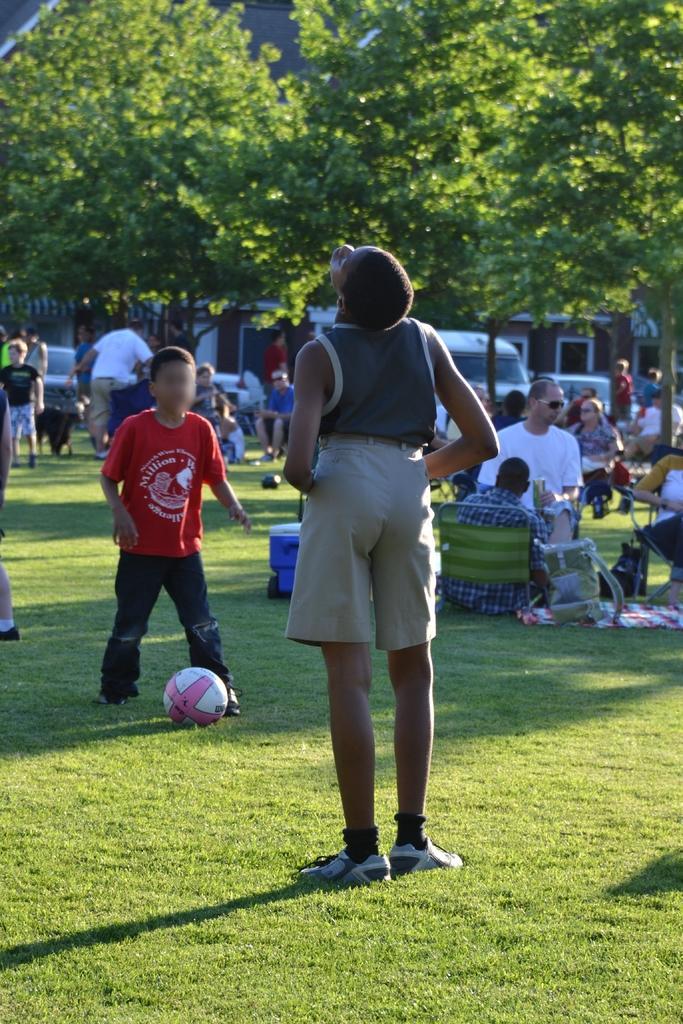Can you describe this image briefly? In this image we can see a group of people on the ground, some people are standing and some are sitting on chairs. In the foreground of the image we can see a ball, a container and bag placed on the grass field. In the background, we can see some vehicles parked on the ground, we can also see buildings with windows. At the top of the image we can see some trees. 